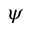Convert formula to latex. <formula><loc_0><loc_0><loc_500><loc_500>\psi</formula> 